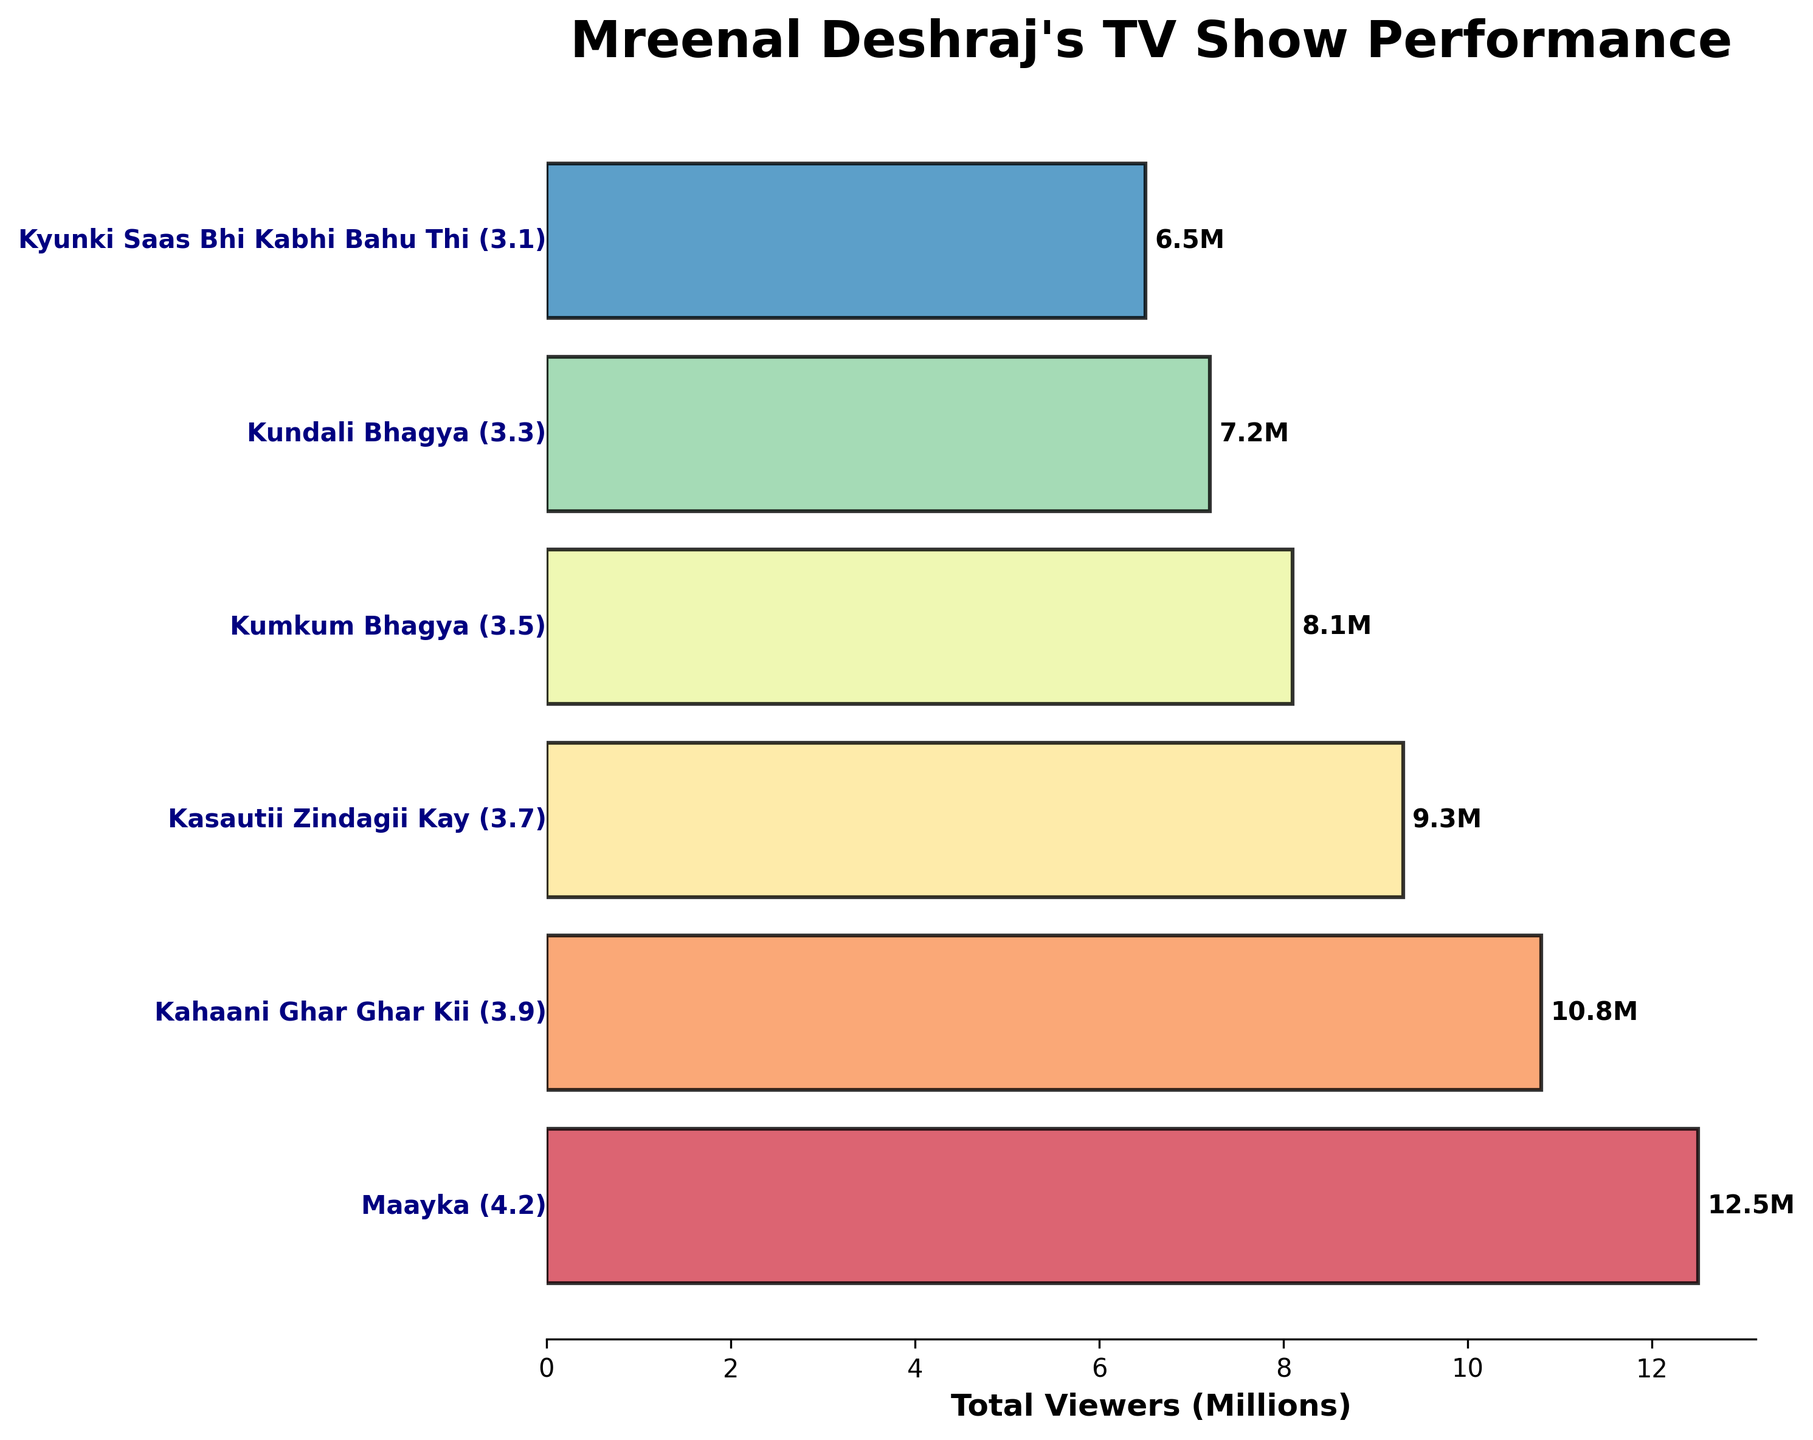What is the title of the plot? The title of the plot is prominently displayed at the top of the figure. It provides a summary of what the plot is about.
Answer: Mreenal Deshraj's TV Show Performance How many TV shows are listed in the plot? Count the number of horizontal bars in the figure, each representing a different TV show.
Answer: 6 Which TV show had the highest total viewers in millions? Identify the longest horizontal bar in the plot, which corresponds to the highest total viewers.
Answer: Maayka Which show had the lowest rating? Locate the TV show with the lowest numerical value in parentheses next to the show name.
Answer: Kyunki Saas Bhi Kabhi Bahu Thi What is the average rating of the TV shows listed? Sum all the ratings provided in parentheses and divide by the number of TV shows. Calculation: (4.2 + 3.9 + 3.7 + 3.5 + 3.3 + 3.1) / 6
Answer: 3.62 How much higher is the rating of "Maayka" compared to "Kyunki Saas Bhi Kabhi Bahu Thi"? Subtract the rating of "Kyunki Saas Bhi Kabhi Bahu Thi" from the rating of "Maayka". Calculation: 4.2 - 3.1
Answer: 1.1 Between "Kahaani Ghar Ghar Kii" and "Kasautii Zindagii Kay", which show had more total viewers and by how much? Compare the total viewers for both TV shows and find the difference. Calculation: 10.8 - 9.3
Answer: Kahaani Ghar Ghar Kii by 1.5 million Order the shows based on their ratings from highest to lowest. List each show in descending order based on the rating values provided in parentheses.
Answer: Maayka, Kahaani Ghar Ghar Kii, Kasautii Zindagii Kay, Kumkum Bhagya, Kundali Bhagya, Kyunki Saas Bhi Kabhi Bahu Thi What percentage of the total viewers (summing all shows) did "Kundali Bhagya" capture? Calculate the total viewers by summing all values. Then, find the percentage that "Kundali Bhagya" represents. Calculation: Total viewers = 12.5 + 10.8 + 9.3 + 8.1 + 7.2 + 6.5 = 54.4 million; Percentage = (7.2 / 54.4) * 100
Answer: 13.24% 